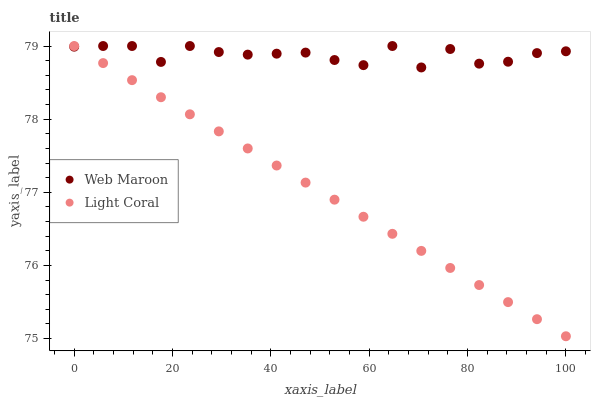Does Light Coral have the minimum area under the curve?
Answer yes or no. Yes. Does Web Maroon have the maximum area under the curve?
Answer yes or no. Yes. Does Web Maroon have the minimum area under the curve?
Answer yes or no. No. Is Light Coral the smoothest?
Answer yes or no. Yes. Is Web Maroon the roughest?
Answer yes or no. Yes. Is Web Maroon the smoothest?
Answer yes or no. No. Does Light Coral have the lowest value?
Answer yes or no. Yes. Does Web Maroon have the lowest value?
Answer yes or no. No. Does Web Maroon have the highest value?
Answer yes or no. Yes. Does Web Maroon intersect Light Coral?
Answer yes or no. Yes. Is Web Maroon less than Light Coral?
Answer yes or no. No. Is Web Maroon greater than Light Coral?
Answer yes or no. No. 